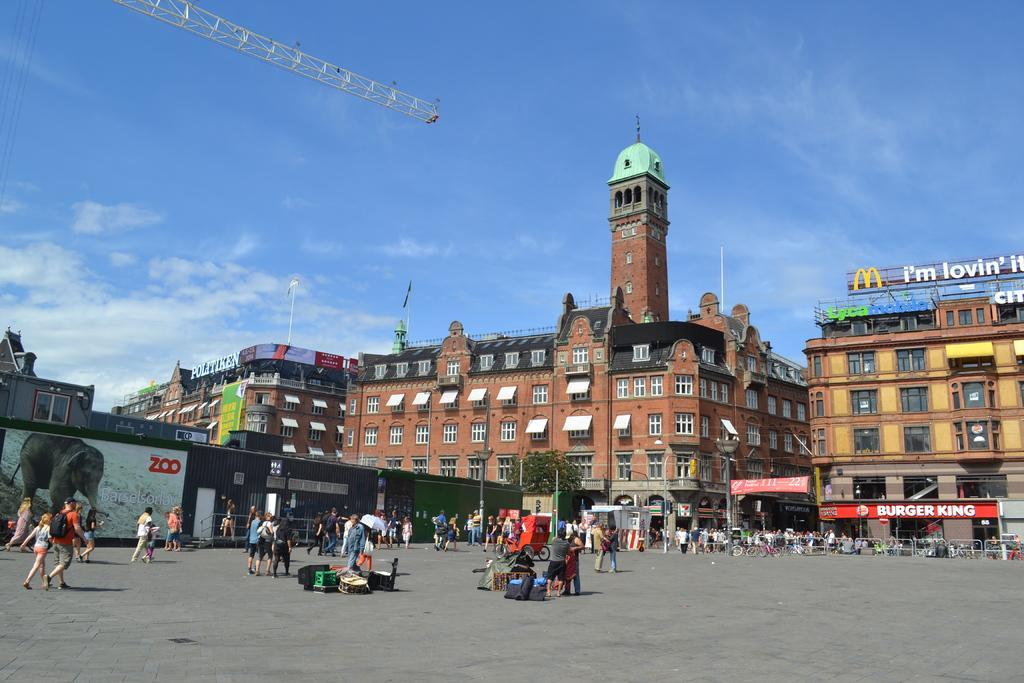Could you give a brief overview of what you see in this image? In this picture we can see a group of people are walking on the path and some people are standing. Behind the people there are poles, trees, buildings and a sky. 